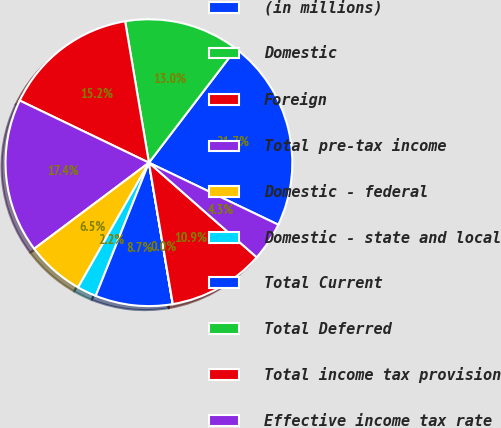Convert chart to OTSL. <chart><loc_0><loc_0><loc_500><loc_500><pie_chart><fcel>(in millions)<fcel>Domestic<fcel>Foreign<fcel>Total pre-tax income<fcel>Domestic - federal<fcel>Domestic - state and local<fcel>Total Current<fcel>Total Deferred<fcel>Total income tax provision<fcel>Effective income tax rate<nl><fcel>21.73%<fcel>13.04%<fcel>15.21%<fcel>17.38%<fcel>6.53%<fcel>2.18%<fcel>8.7%<fcel>0.01%<fcel>10.87%<fcel>4.35%<nl></chart> 